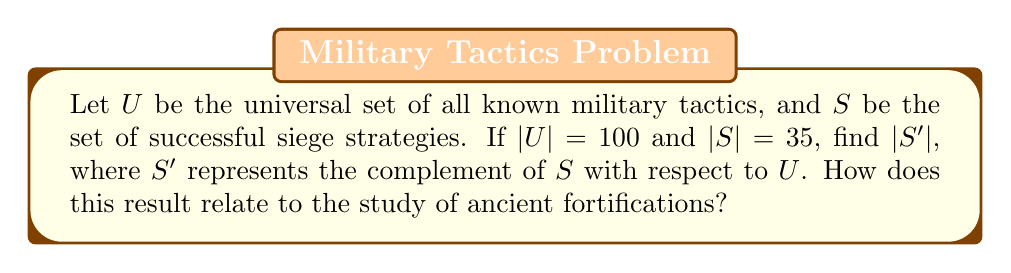Solve this math problem. To solve this problem, we'll follow these steps:

1) First, recall that the complement of a set $A$, denoted $A'$, is the set of all elements in the universal set $U$ that are not in $A$.

2) The relationship between a set and its complement is given by:

   $|U| = |A| + |A'|$

3) In this case, we're given:
   $|U| = 100$ (total number of known military tactics)
   $|S| = 35$ (number of successful siege strategies)

4) We need to find $|S'|$. Using the relationship from step 2:

   $100 = 35 + |S'|$

5) Solving for $|S'|$:

   $|S'| = 100 - 35 = 65$

6) Interpretation: This means there are 65 military tactics that are not successful siege strategies.

7) Relating to ancient fortifications: As a student of ancient tactics, this result is significant because it shows that the majority of military tactics (65 out of 100) are not specific to siege warfare. This highlights the specialized nature of siege tactics and the importance of studying fortifications separately from general military strategy.
Answer: $|S'| = 65$ 